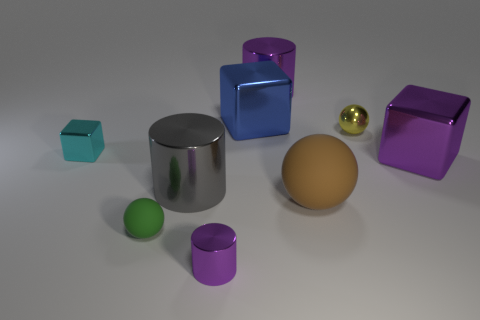Which objects in the image could float if they were placed in water? Without knowing the exact materials or the hollow nature of the objects, it is challenging to ascertain buoyancy solely from visuals. Typically, objects with closed air pockets or made from lightweight, less dense materials than water might float, but this cannot be determined here without additional information. 